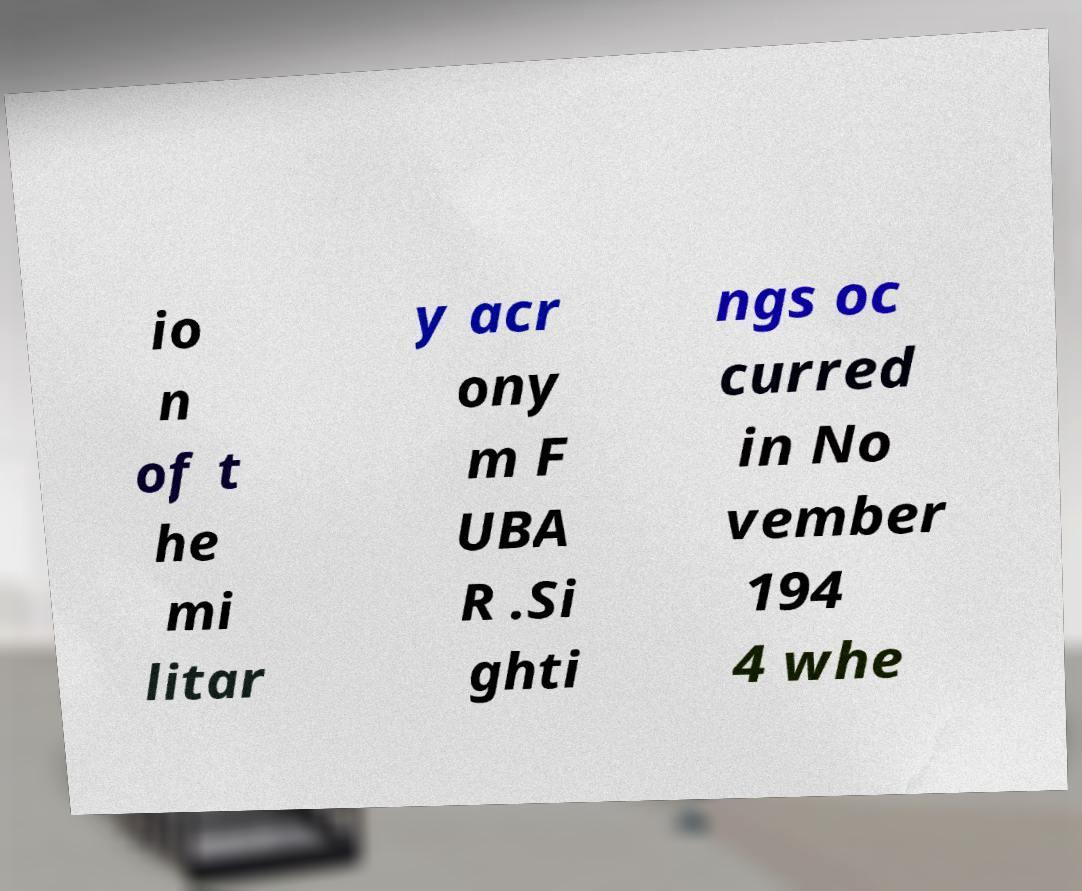For documentation purposes, I need the text within this image transcribed. Could you provide that? io n of t he mi litar y acr ony m F UBA R .Si ghti ngs oc curred in No vember 194 4 whe 